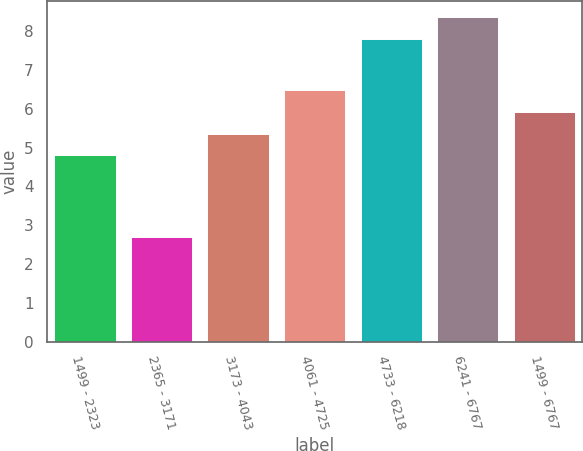<chart> <loc_0><loc_0><loc_500><loc_500><bar_chart><fcel>1499 - 2323<fcel>2365 - 3171<fcel>3173 - 4043<fcel>4061 - 4725<fcel>4733 - 6218<fcel>6241 - 6767<fcel>1499 - 6767<nl><fcel>4.8<fcel>2.7<fcel>5.36<fcel>6.48<fcel>7.8<fcel>8.36<fcel>5.92<nl></chart> 